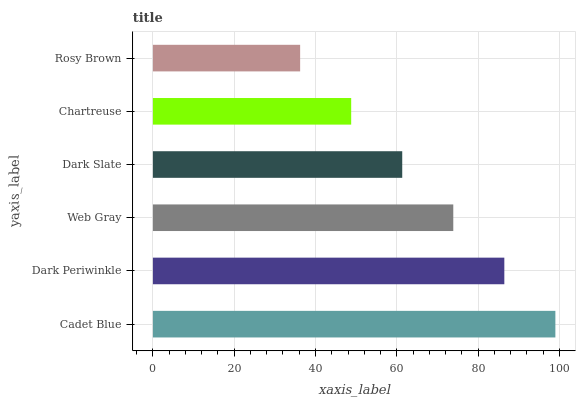Is Rosy Brown the minimum?
Answer yes or no. Yes. Is Cadet Blue the maximum?
Answer yes or no. Yes. Is Dark Periwinkle the minimum?
Answer yes or no. No. Is Dark Periwinkle the maximum?
Answer yes or no. No. Is Cadet Blue greater than Dark Periwinkle?
Answer yes or no. Yes. Is Dark Periwinkle less than Cadet Blue?
Answer yes or no. Yes. Is Dark Periwinkle greater than Cadet Blue?
Answer yes or no. No. Is Cadet Blue less than Dark Periwinkle?
Answer yes or no. No. Is Web Gray the high median?
Answer yes or no. Yes. Is Dark Slate the low median?
Answer yes or no. Yes. Is Rosy Brown the high median?
Answer yes or no. No. Is Cadet Blue the low median?
Answer yes or no. No. 